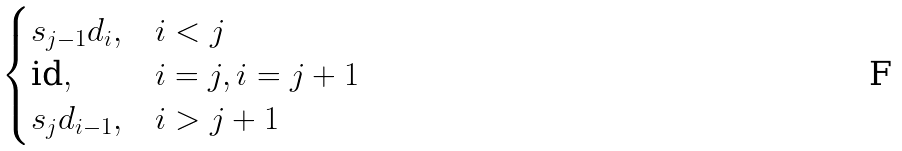<formula> <loc_0><loc_0><loc_500><loc_500>\begin{cases} s _ { j - 1 } d _ { i } , & i < j \\ \text {id} , & i = j , i = j + 1 \\ s _ { j } d _ { i - 1 } , & i > j + 1 \end{cases}</formula> 